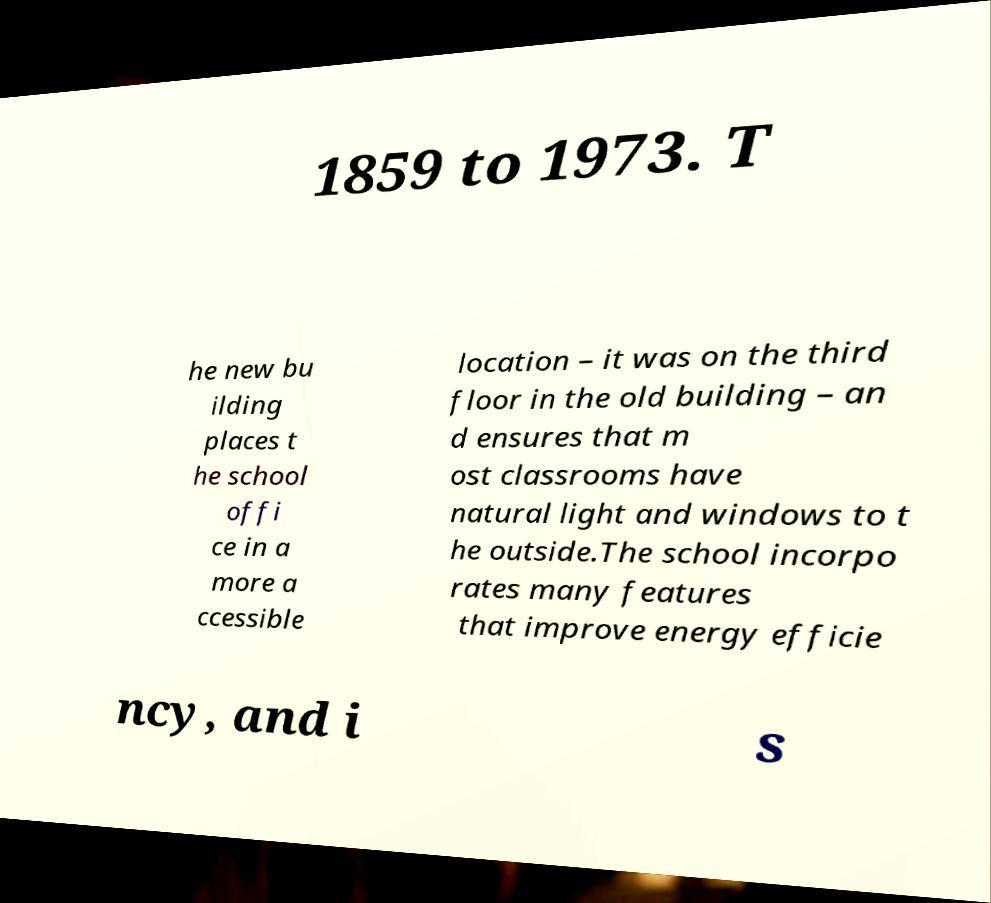Please identify and transcribe the text found in this image. 1859 to 1973. T he new bu ilding places t he school offi ce in a more a ccessible location – it was on the third floor in the old building – an d ensures that m ost classrooms have natural light and windows to t he outside.The school incorpo rates many features that improve energy efficie ncy, and i s 